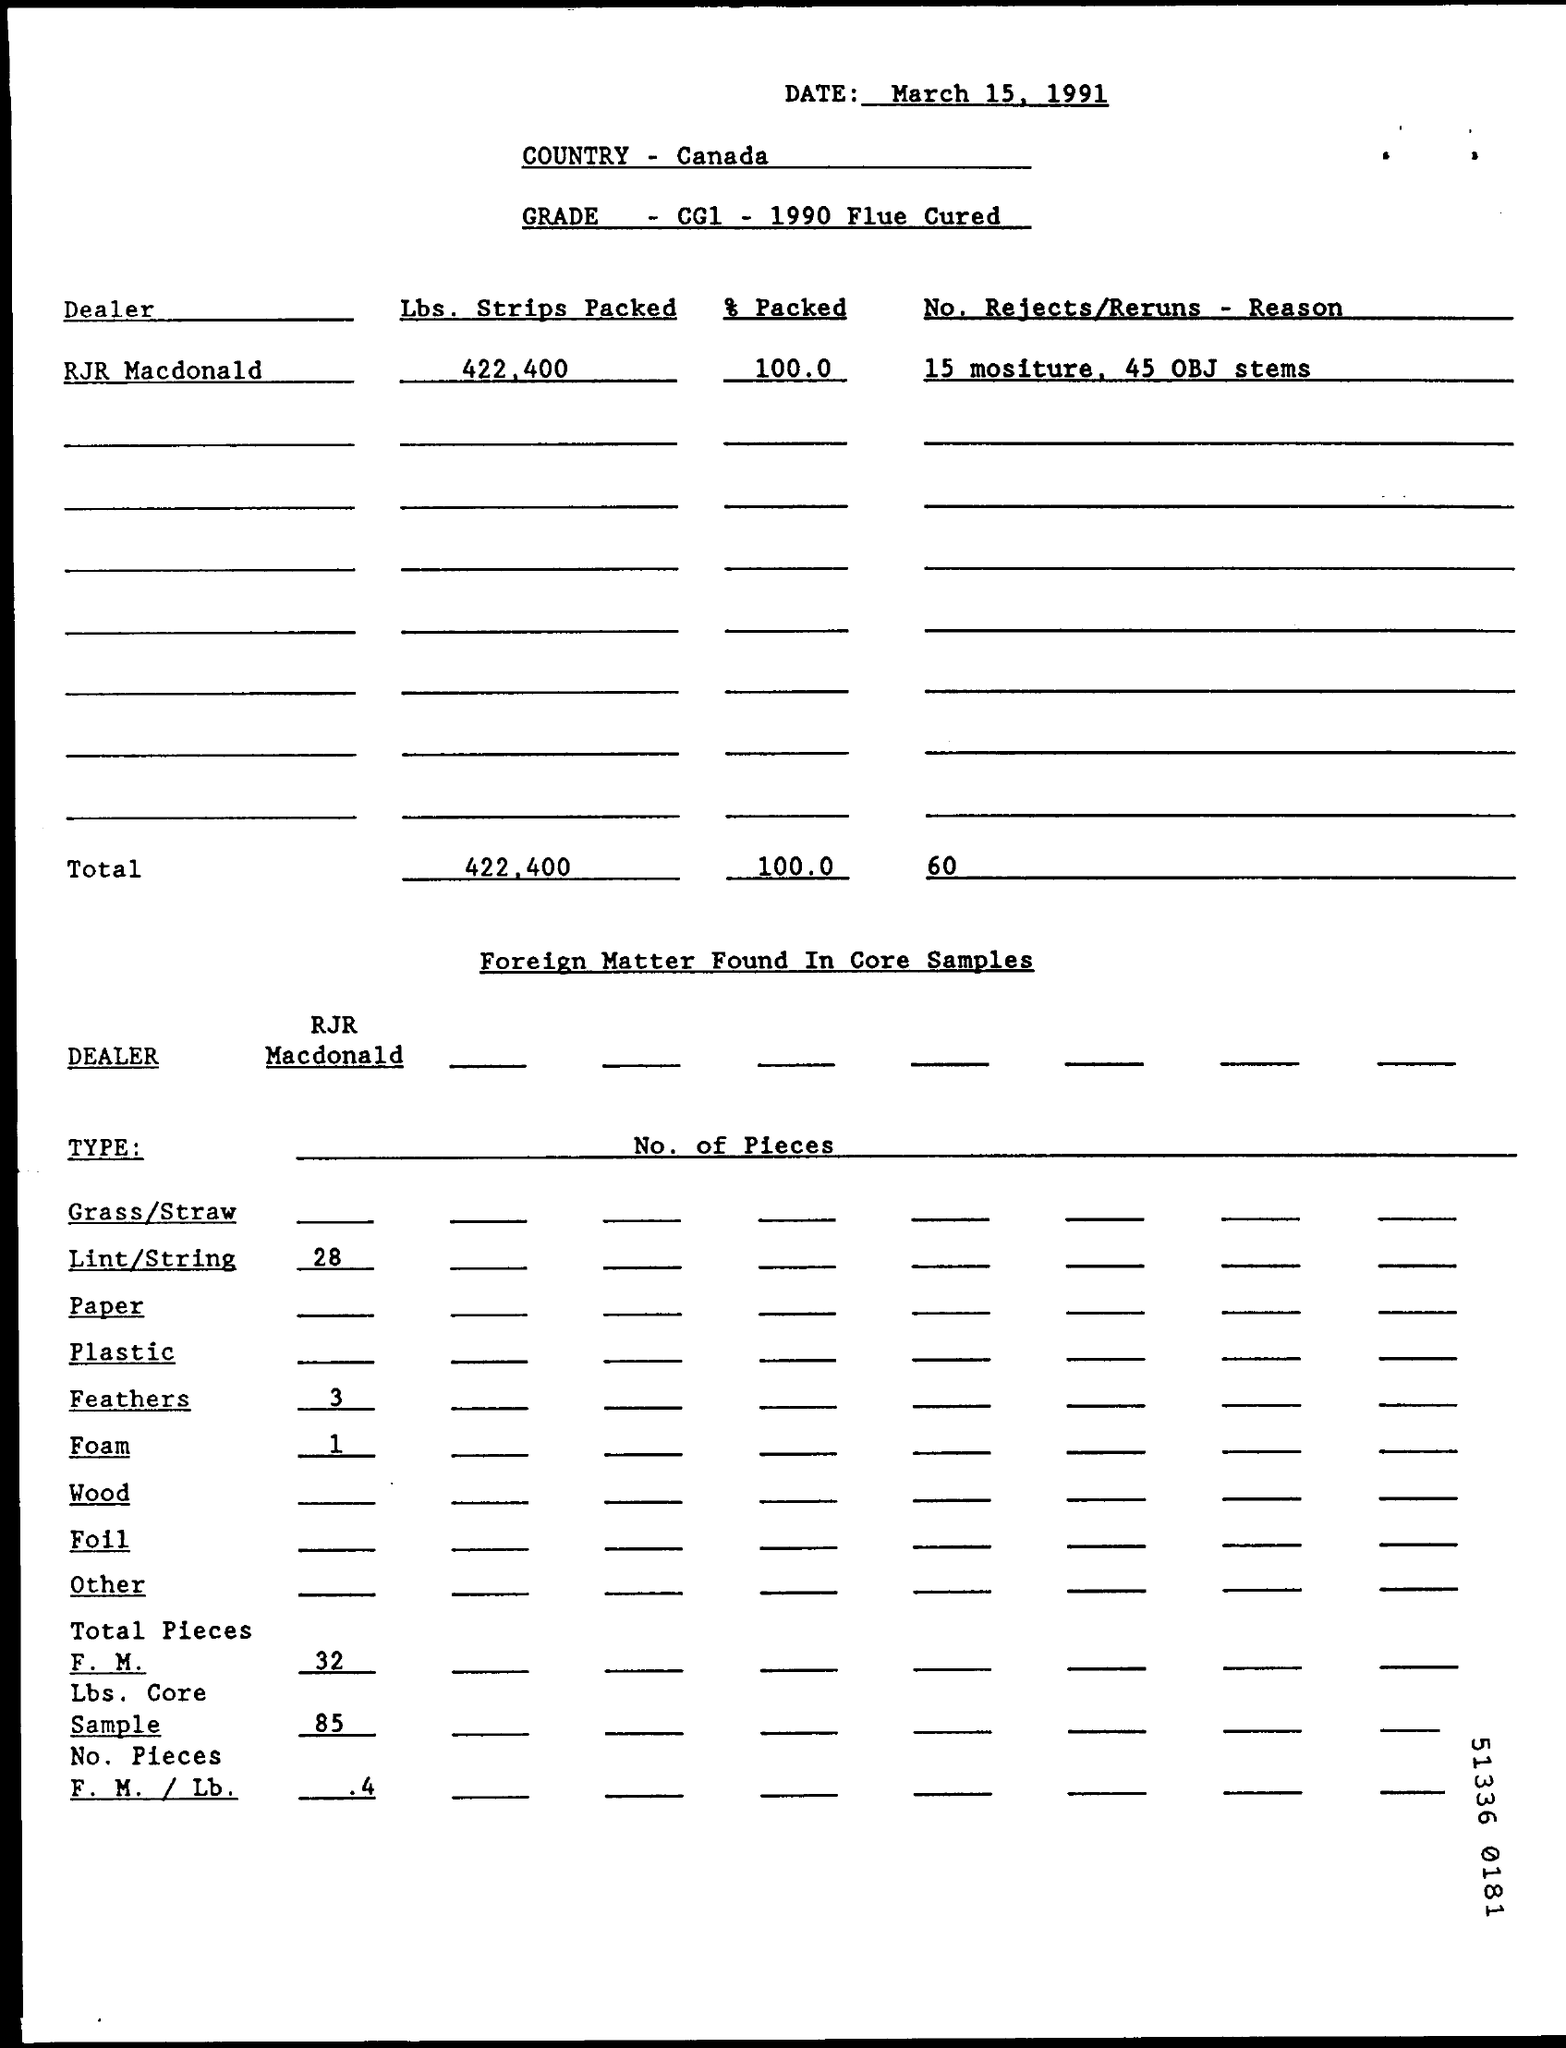Give some essential details in this illustration. Canada is the country that is mentioned. The document is dated March 15, 1991. The grade specified is CG1, which was produced in 1990 and is of flue-cured tobacco variety. 